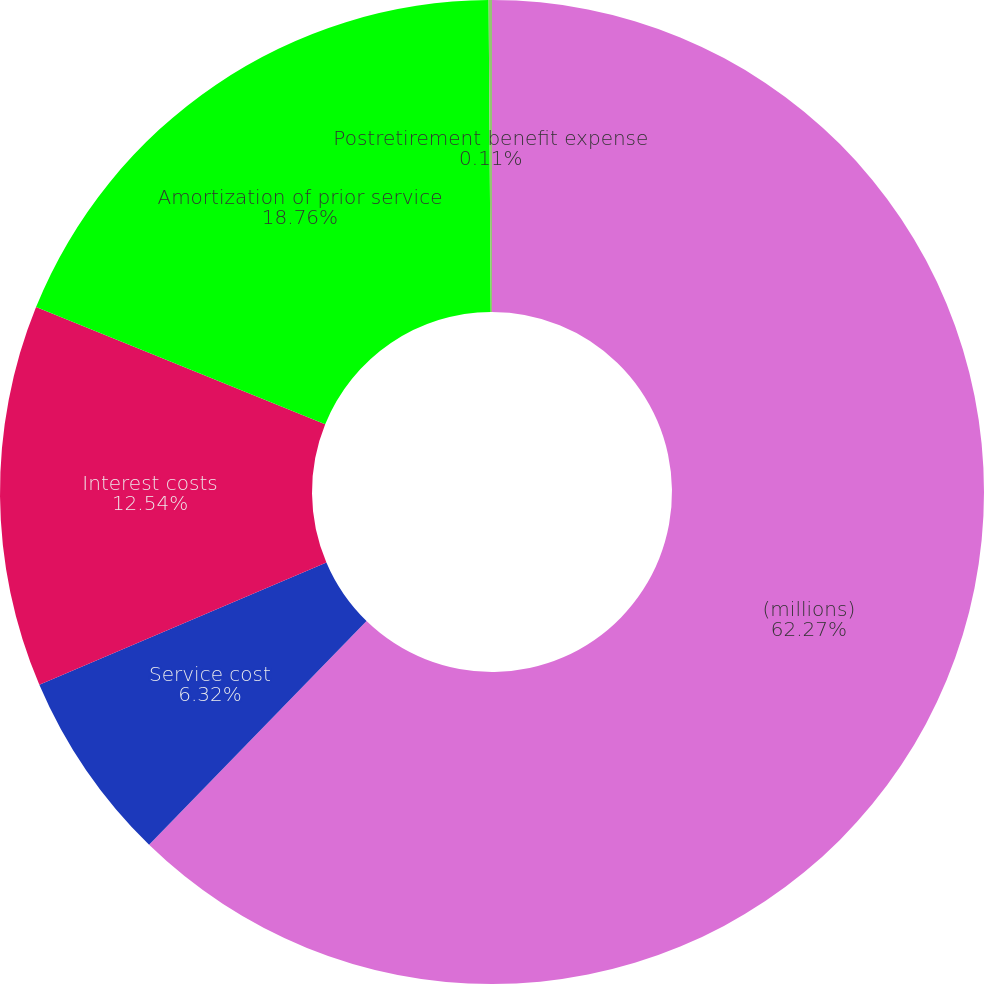Convert chart to OTSL. <chart><loc_0><loc_0><loc_500><loc_500><pie_chart><fcel>(millions)<fcel>Service cost<fcel>Interest costs<fcel>Amortization of prior service<fcel>Postretirement benefit expense<nl><fcel>62.28%<fcel>6.32%<fcel>12.54%<fcel>18.76%<fcel>0.11%<nl></chart> 